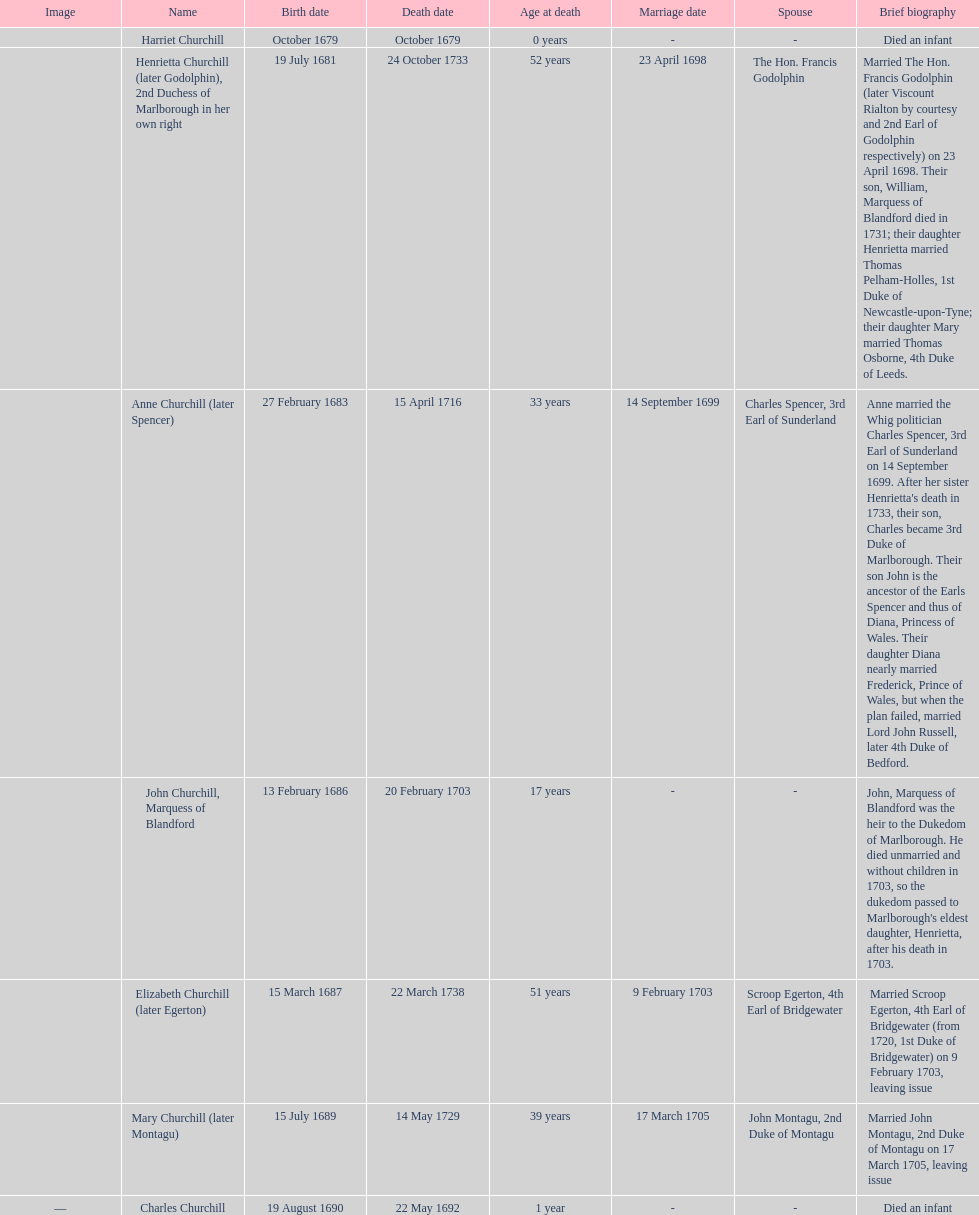What is the total number of children listed? 7. 